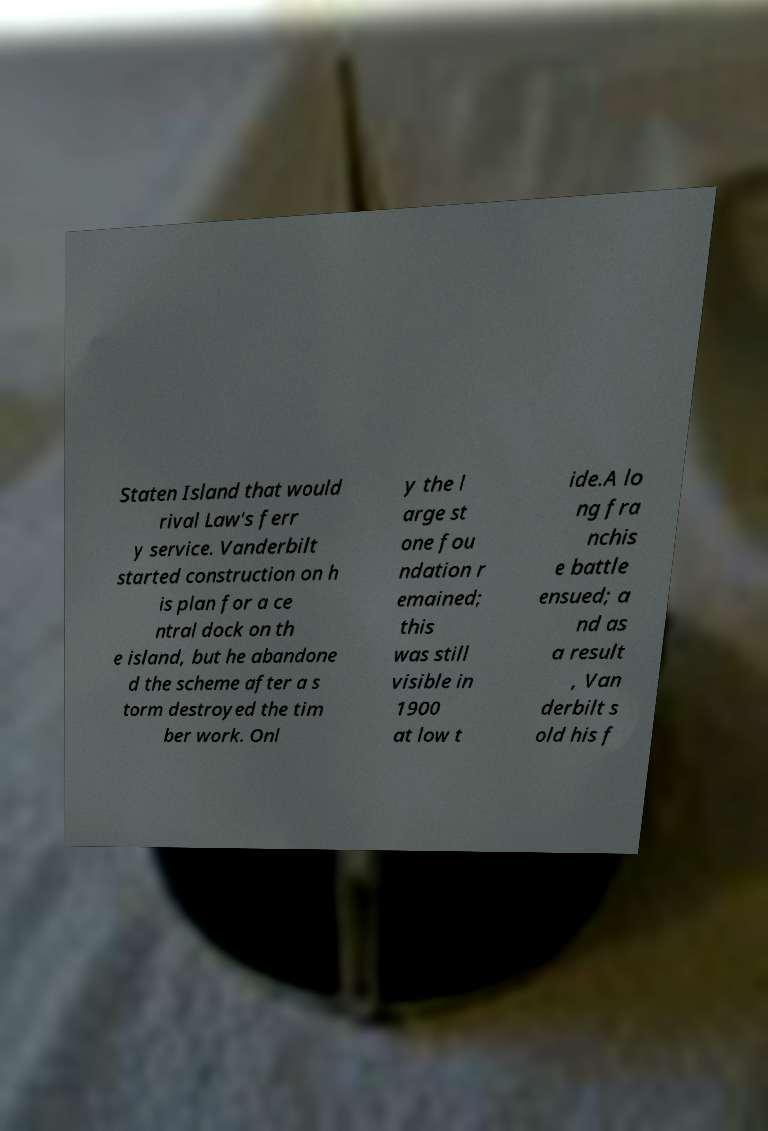What messages or text are displayed in this image? I need them in a readable, typed format. Staten Island that would rival Law's ferr y service. Vanderbilt started construction on h is plan for a ce ntral dock on th e island, but he abandone d the scheme after a s torm destroyed the tim ber work. Onl y the l arge st one fou ndation r emained; this was still visible in 1900 at low t ide.A lo ng fra nchis e battle ensued; a nd as a result , Van derbilt s old his f 